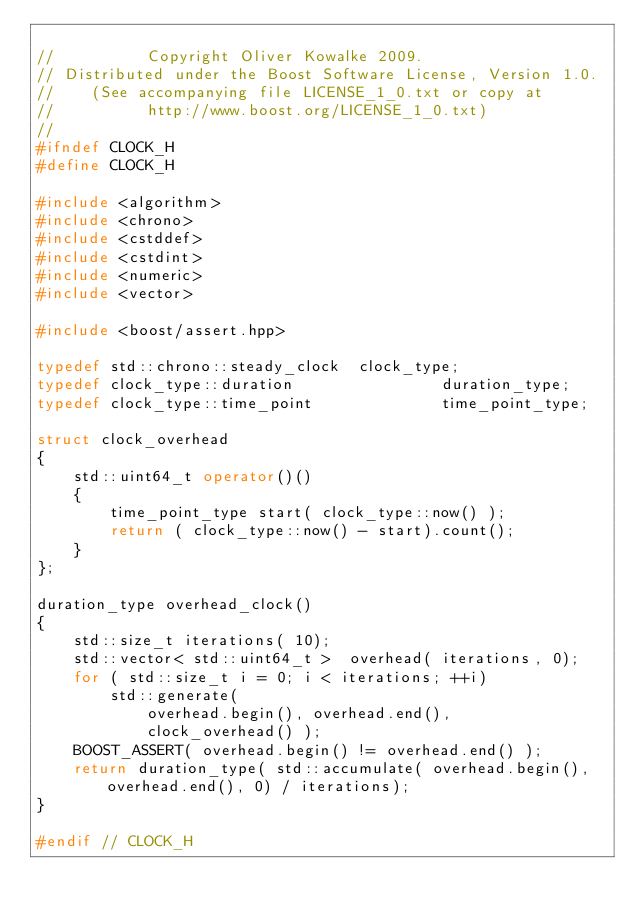Convert code to text. <code><loc_0><loc_0><loc_500><loc_500><_C++_>
//          Copyright Oliver Kowalke 2009.
// Distributed under the Boost Software License, Version 1.0.
//    (See accompanying file LICENSE_1_0.txt or copy at
//          http://www.boost.org/LICENSE_1_0.txt)
//
#ifndef CLOCK_H
#define CLOCK_H

#include <algorithm>
#include <chrono>
#include <cstddef>
#include <cstdint>
#include <numeric>
#include <vector>

#include <boost/assert.hpp>

typedef std::chrono::steady_clock  clock_type;
typedef clock_type::duration                duration_type;
typedef clock_type::time_point              time_point_type;

struct clock_overhead
{
    std::uint64_t operator()()
    {
        time_point_type start( clock_type::now() );
        return ( clock_type::now() - start).count();
    }
};

duration_type overhead_clock()
{
    std::size_t iterations( 10);
    std::vector< std::uint64_t >  overhead( iterations, 0);
    for ( std::size_t i = 0; i < iterations; ++i)
        std::generate(
            overhead.begin(), overhead.end(),
            clock_overhead() );
    BOOST_ASSERT( overhead.begin() != overhead.end() );
    return duration_type( std::accumulate( overhead.begin(), overhead.end(), 0) / iterations);
}

#endif // CLOCK_H
</code> 